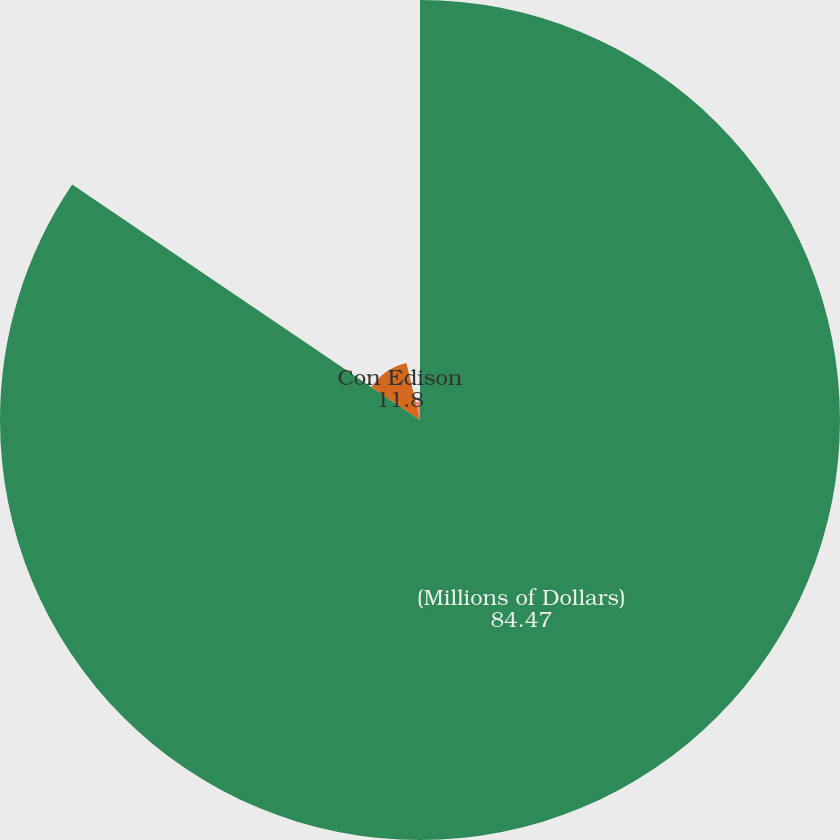Convert chart. <chart><loc_0><loc_0><loc_500><loc_500><pie_chart><fcel>(Millions of Dollars)<fcel>Con Edison<fcel>CECONY<nl><fcel>84.47%<fcel>11.8%<fcel>3.73%<nl></chart> 